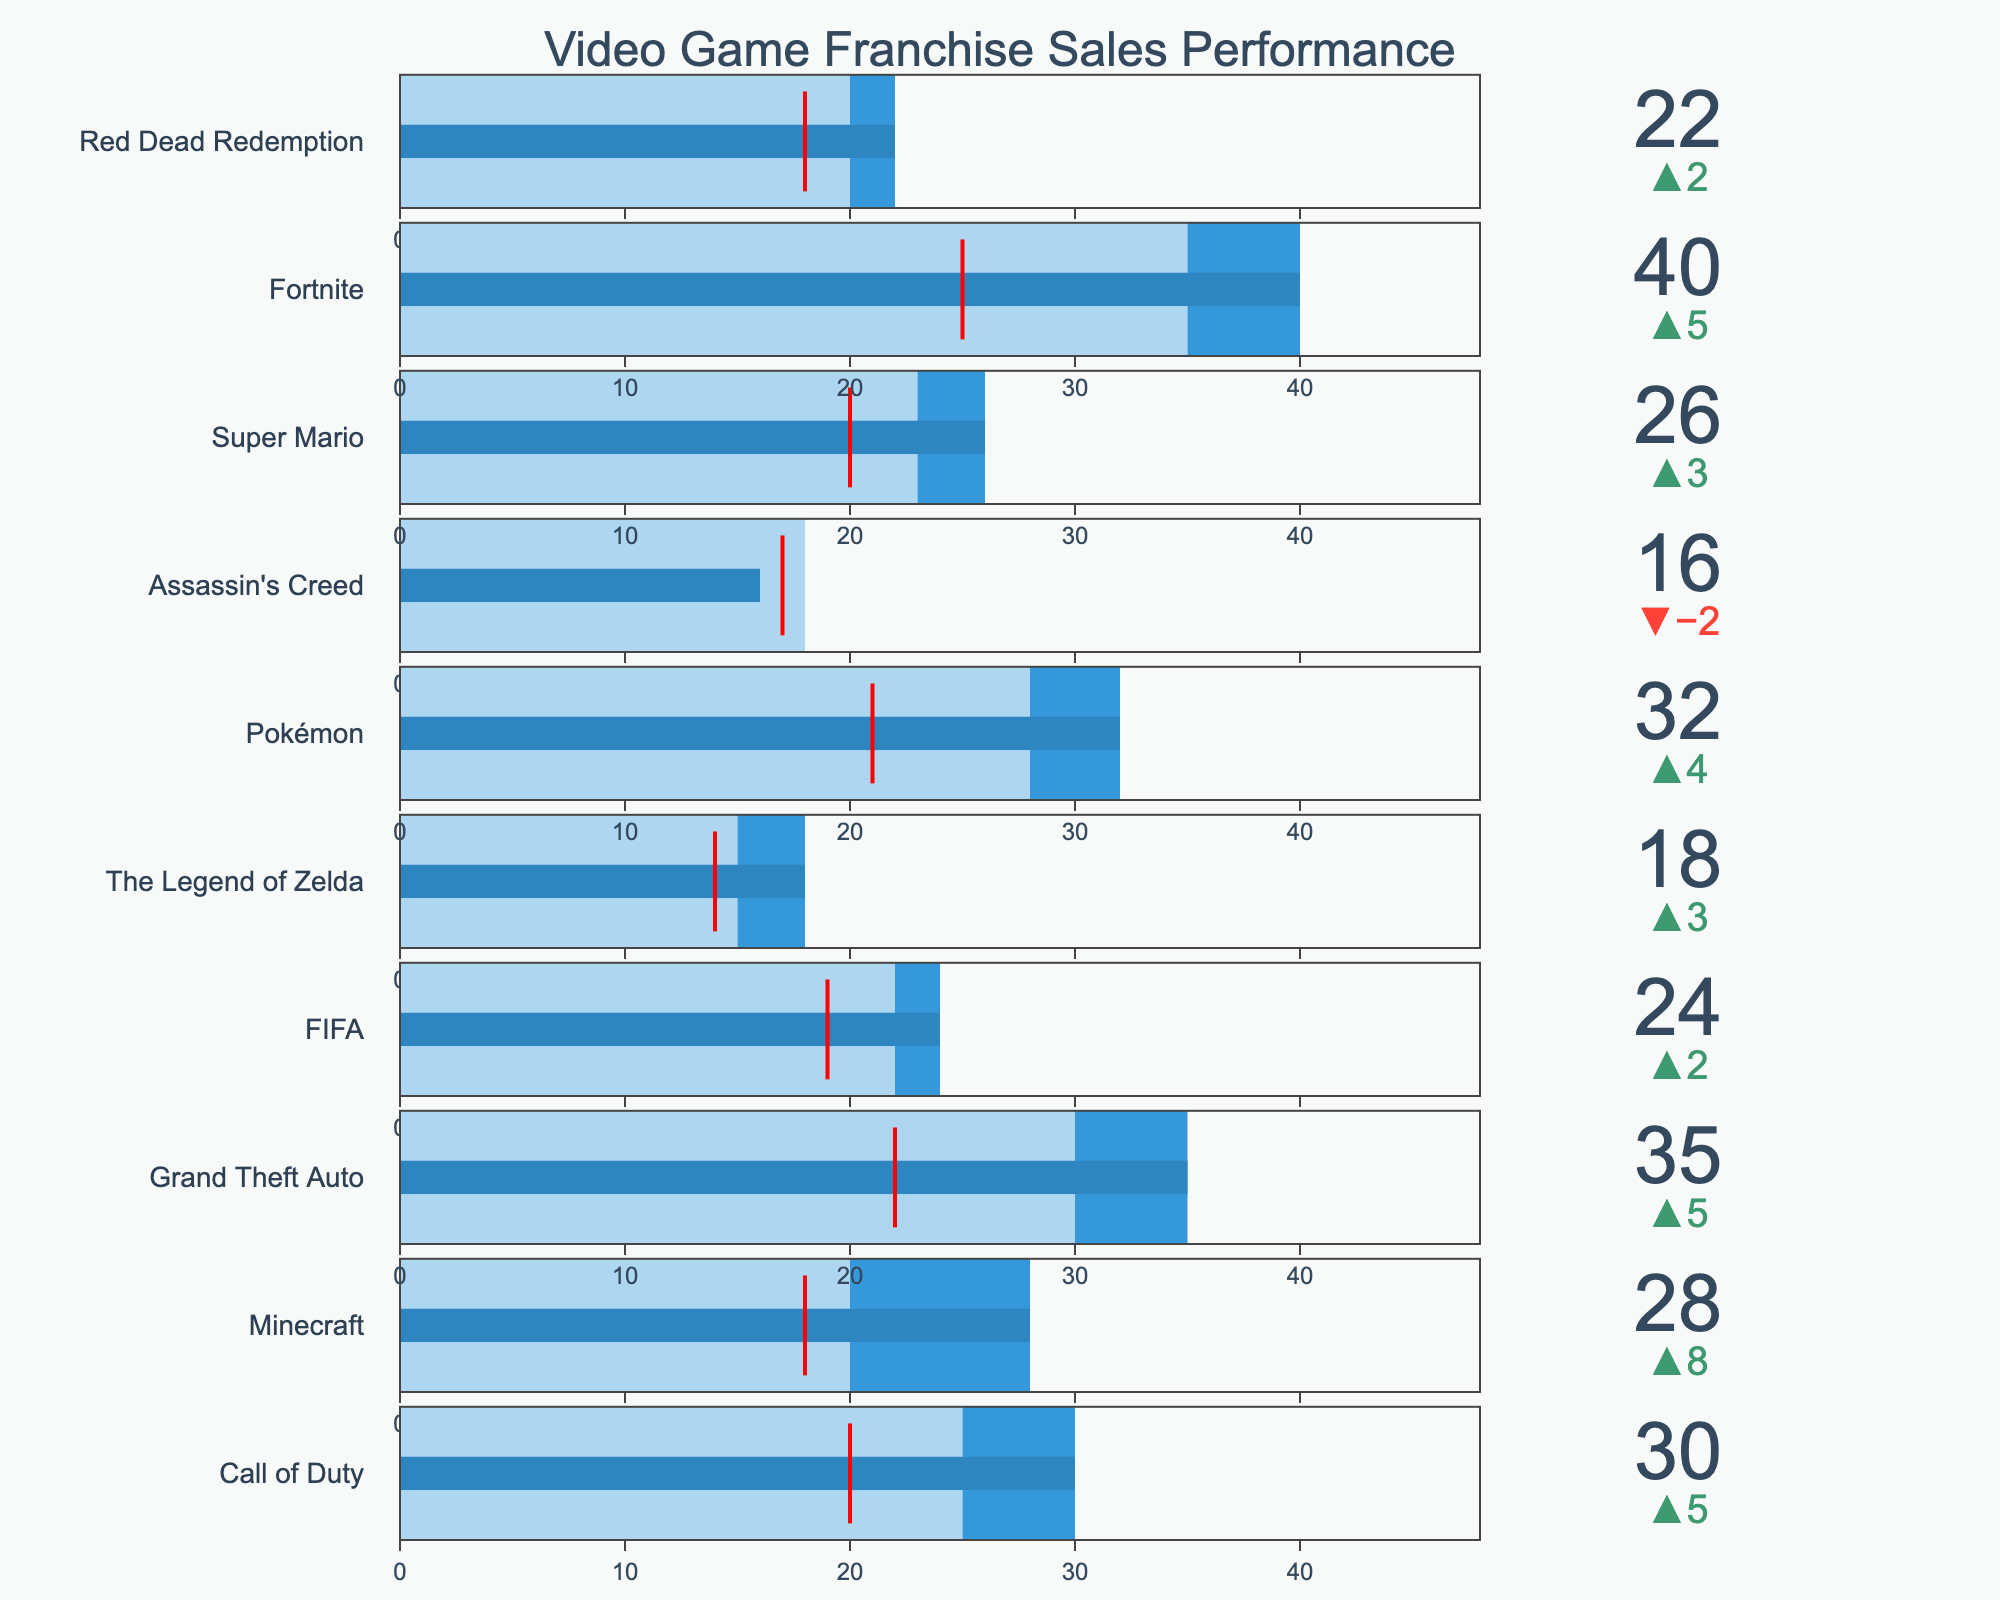What is the title of the figure? The title can be found at the top of the chart. It provides a summary of what the chart is demonstrating.
Answer: Video Game Franchise Sales Performance Which franchise has the highest actual sales? To find this, we need to look at the bullet chart and identify the franchise with the longest bar (in blue color) representing the actual sales value.
Answer: Fortnite How does Call of Duty's actual sales compare to its target sales? To answer this, inspect Call of Duty's bullet indicator. The delta value will show the difference between its actual sales and target sales. If the actual sales bar extends past the target sales range represented in blue, it indicates higher sales.
Answer: 5 million more What is the industry average sales value for Grand Theft Auto? For this, look specifically at the gauge threshold for Grand Theft Auto, indicated by a red line.
Answer: 22 million Which franchise exceeded its target sales by the largest amount? Compare the delta values (difference between actual and target sales) for all franchises. The franchise with the largest positive delta exceeded its target sales the most.
Answer: Fortnite How do the actual sales of FIFA compare to the industry average? Compare FIFA's actual sales bar to the threshold red line representing the industry average. If the bar extends past the red line, it is higher than the industry average.
Answer: Higher by 5 million What is the difference between target and actual sales for Assassin's Creed? Look at the delta value presented for Assassin's Creed. This delta shows the difference between the target and actual sales.
Answer: 2 million less Which franchises have actual sales above the industry average? Check if the blue bars (actual sales) for each franchise extend past the red threshold line (industry average). List all these franchises.
Answer: Call of Duty, Minecraft, Grand Theft Auto, FIFA, The Legend of Zelda, Pokémon, Super Mario, Fortnite, Red Dead Redemption How do Minecraft's target sales compare to the industry average sales? Compare the length of Minecraft's target sales range (in the lighter blue section) to the position of the red threshold line indicating the industry average. If the target range is shorter than the threshold line, the target is lower than the industry average.
Answer: Higher by 2 million Which franchise has actual sales closest to its target sales, and how close are they? Look at the delta values for all franchises. The one with the smallest delta value indicates the closest match between actual and target sales. Report the name of the franchise and the delta value.
Answer: FIFA, 2 million 